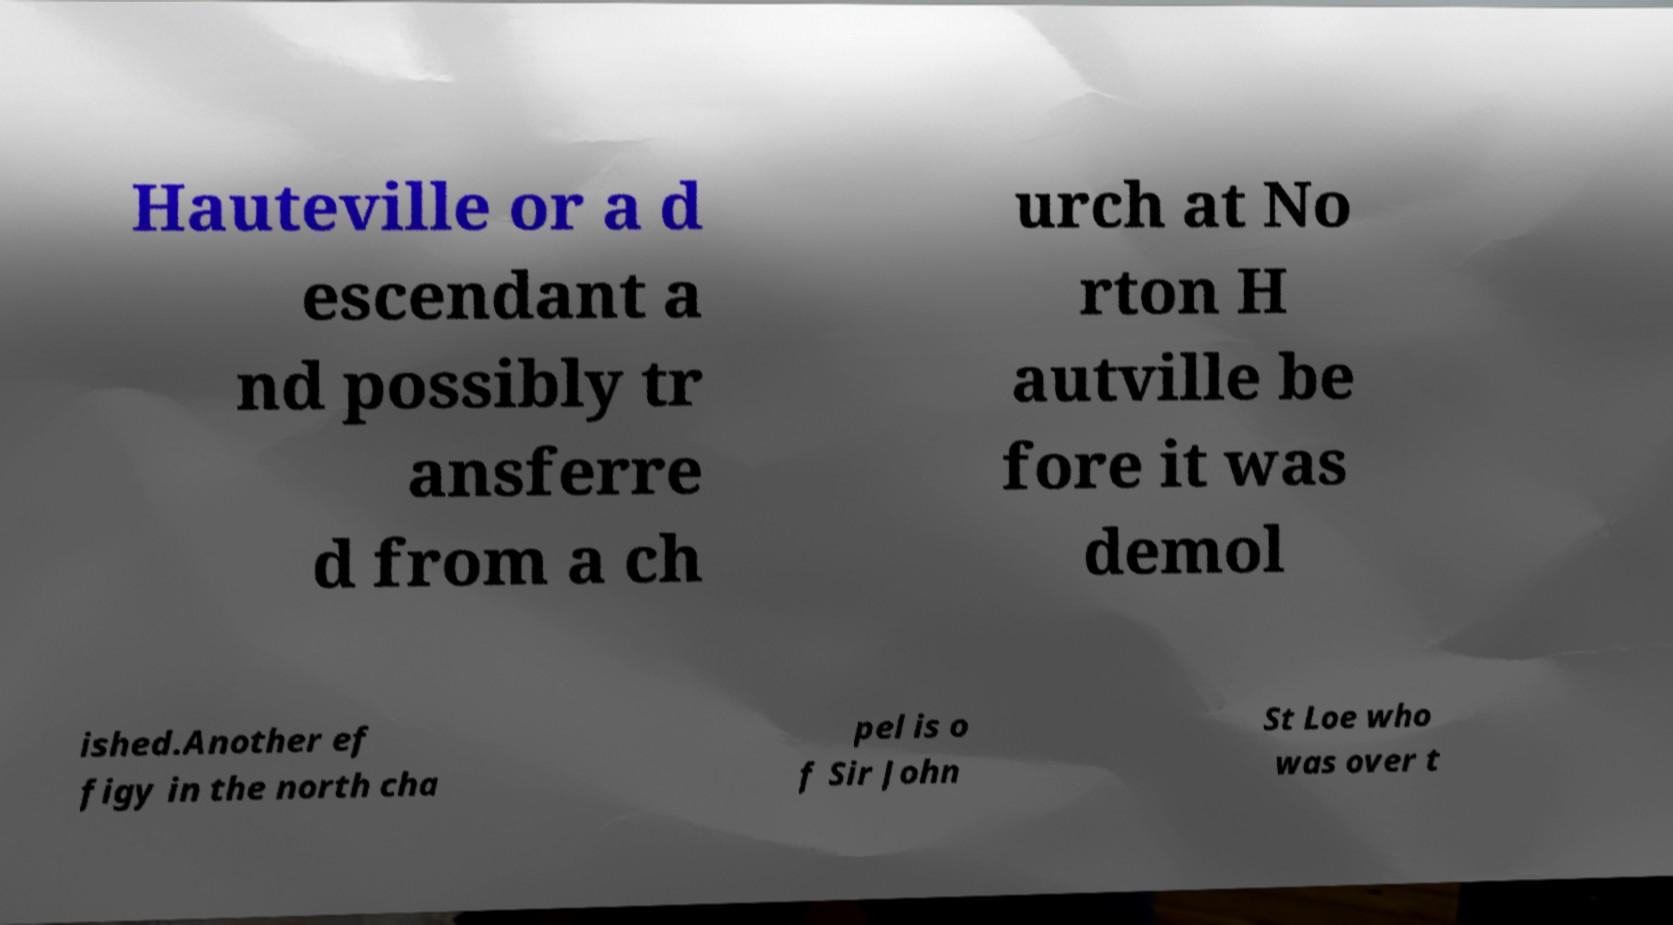Can you read and provide the text displayed in the image?This photo seems to have some interesting text. Can you extract and type it out for me? Hauteville or a d escendant a nd possibly tr ansferre d from a ch urch at No rton H autville be fore it was demol ished.Another ef figy in the north cha pel is o f Sir John St Loe who was over t 